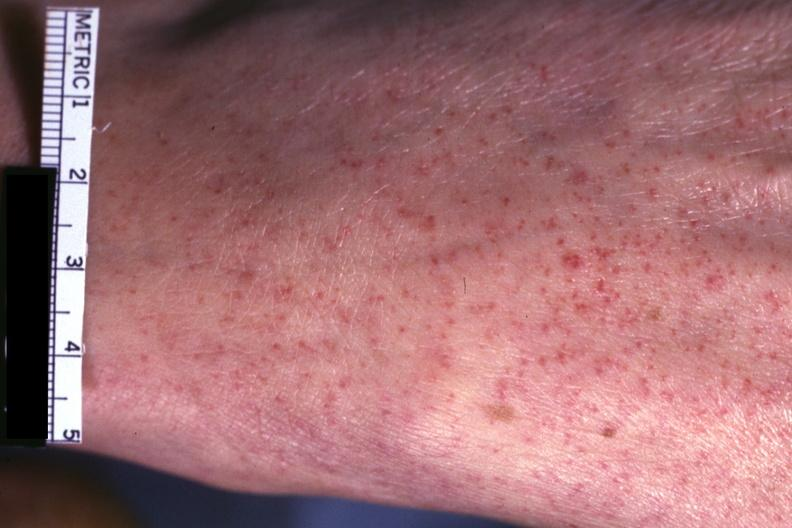s ulcer present?
Answer the question using a single word or phrase. No 